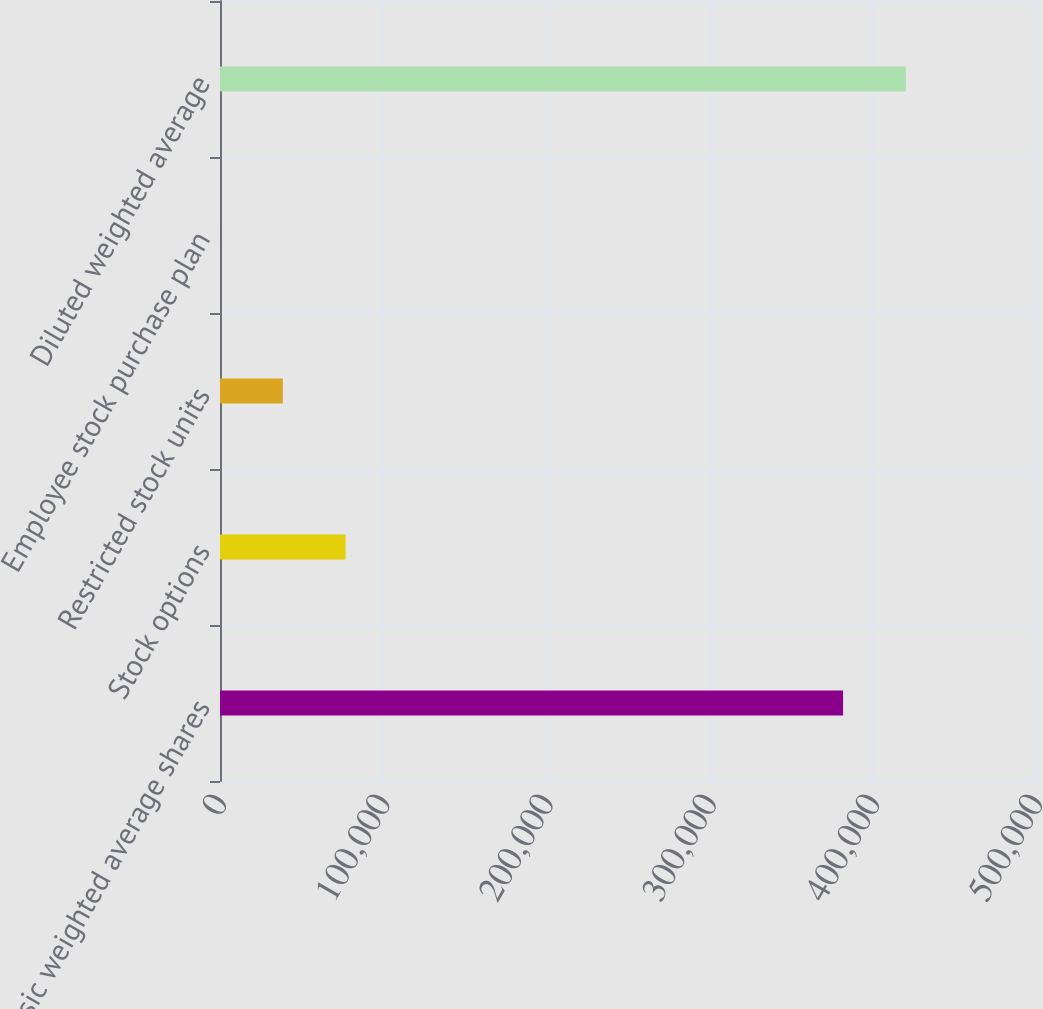<chart> <loc_0><loc_0><loc_500><loc_500><bar_chart><fcel>Basic weighted average shares<fcel>Stock options<fcel>Restricted stock units<fcel>Employee stock purchase plan<fcel>Diluted weighted average<nl><fcel>381782<fcel>76949.2<fcel>38497.1<fcel>45<fcel>420234<nl></chart> 